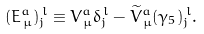<formula> <loc_0><loc_0><loc_500><loc_500>( E _ { \, \mu } ^ { a } ) _ { j } ^ { \, l } \equiv V _ { \, \mu } ^ { a } \delta _ { j } ^ { \, l } - { \widetilde { V } } _ { \, \mu } ^ { a } ( \gamma _ { 5 } ) _ { j } ^ { \, l } .</formula> 